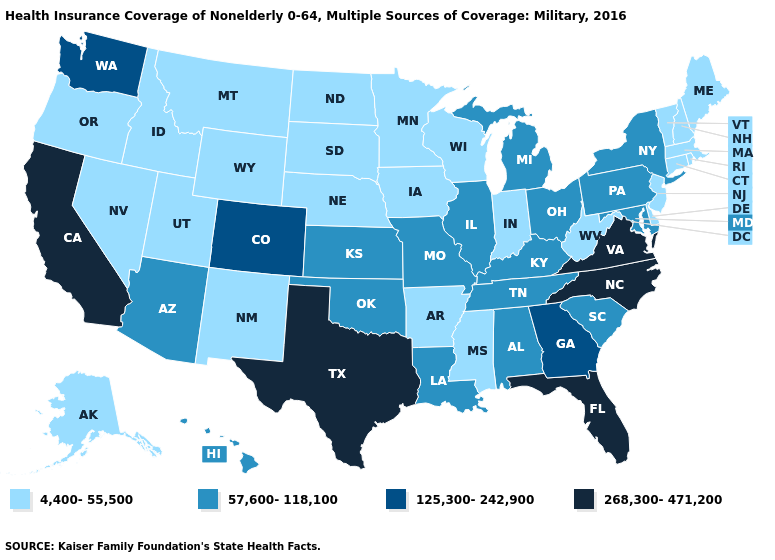Name the states that have a value in the range 125,300-242,900?
Give a very brief answer. Colorado, Georgia, Washington. Among the states that border South Carolina , does Georgia have the lowest value?
Be succinct. Yes. Which states hav the highest value in the MidWest?
Be succinct. Illinois, Kansas, Michigan, Missouri, Ohio. Does Alaska have the lowest value in the USA?
Write a very short answer. Yes. Name the states that have a value in the range 57,600-118,100?
Answer briefly. Alabama, Arizona, Hawaii, Illinois, Kansas, Kentucky, Louisiana, Maryland, Michigan, Missouri, New York, Ohio, Oklahoma, Pennsylvania, South Carolina, Tennessee. What is the value of Delaware?
Short answer required. 4,400-55,500. What is the value of California?
Write a very short answer. 268,300-471,200. Does South Dakota have the same value as Pennsylvania?
Short answer required. No. Name the states that have a value in the range 57,600-118,100?
Give a very brief answer. Alabama, Arizona, Hawaii, Illinois, Kansas, Kentucky, Louisiana, Maryland, Michigan, Missouri, New York, Ohio, Oklahoma, Pennsylvania, South Carolina, Tennessee. Among the states that border Oklahoma , does Kansas have the lowest value?
Be succinct. No. What is the value of New Jersey?
Write a very short answer. 4,400-55,500. Among the states that border New Hampshire , which have the lowest value?
Give a very brief answer. Maine, Massachusetts, Vermont. What is the highest value in the USA?
Be succinct. 268,300-471,200. Which states have the lowest value in the Northeast?
Short answer required. Connecticut, Maine, Massachusetts, New Hampshire, New Jersey, Rhode Island, Vermont. 